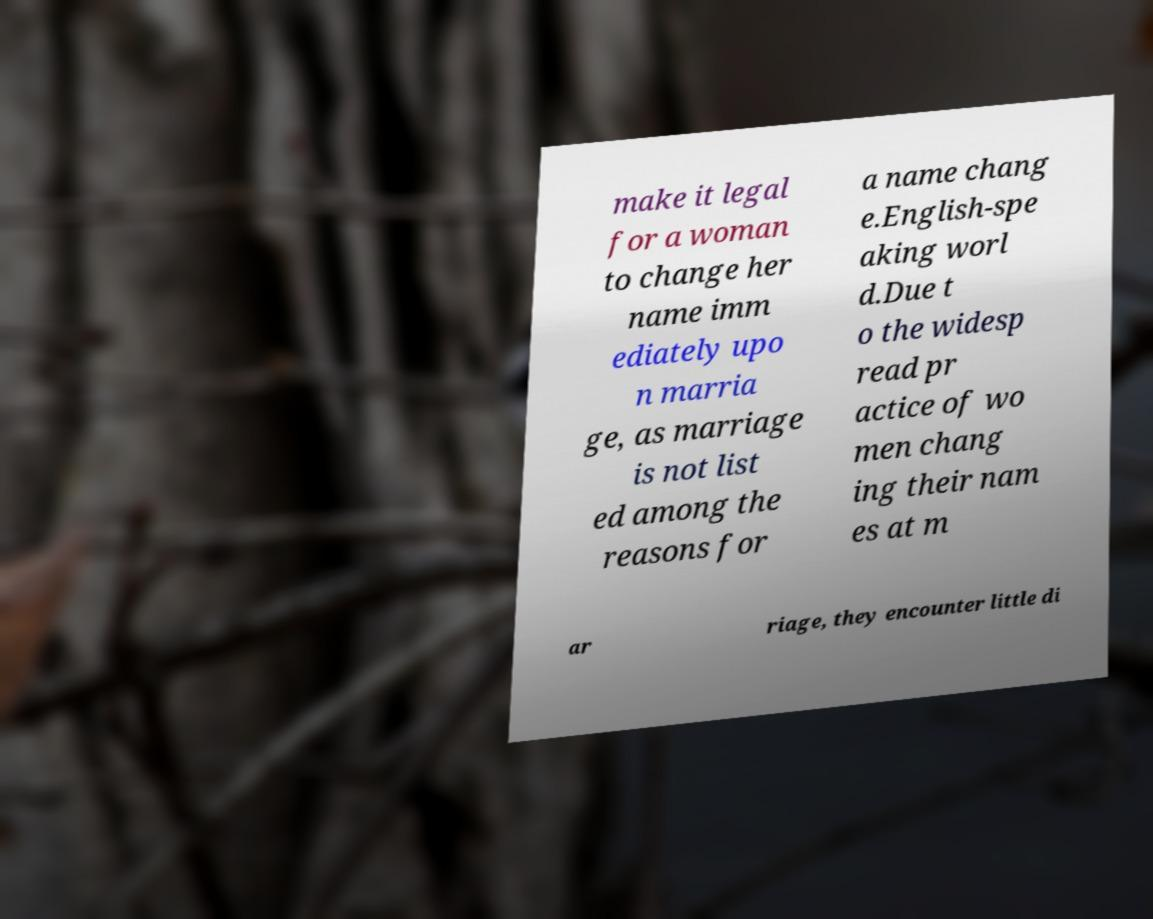Please identify and transcribe the text found in this image. make it legal for a woman to change her name imm ediately upo n marria ge, as marriage is not list ed among the reasons for a name chang e.English-spe aking worl d.Due t o the widesp read pr actice of wo men chang ing their nam es at m ar riage, they encounter little di 